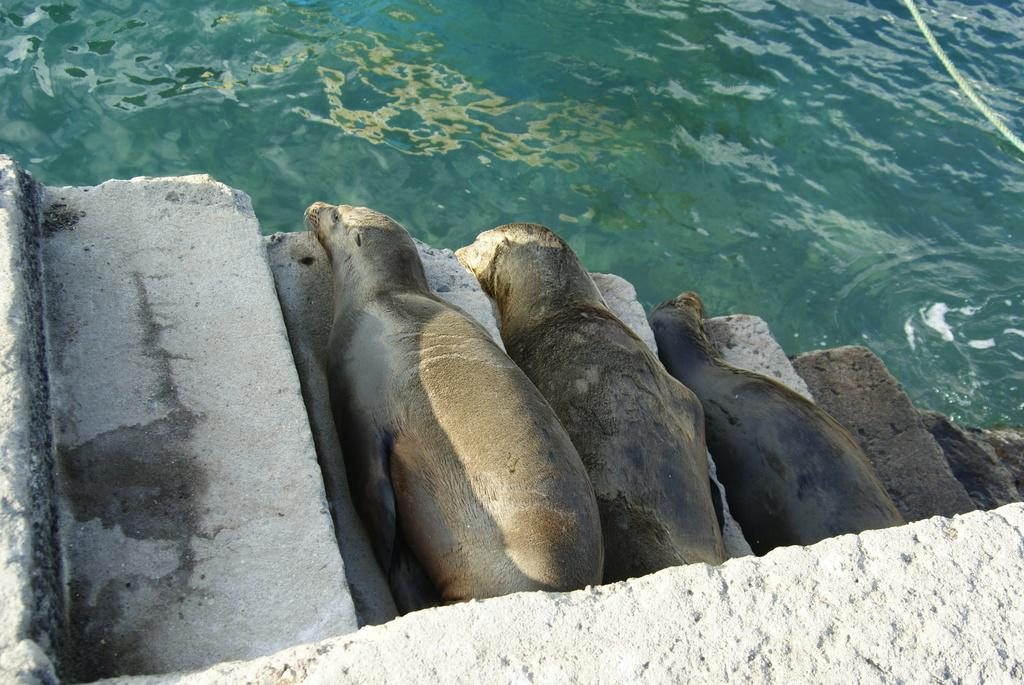What is the primary element in the image? There is water in the image. What is the color of the water? The water is blue in color. Are there any structures near the water? Yes, there are steps near the water. What are the sea lions doing in the image? The sea lions are sleeping on the steps. What type of angle is being used to take the picture of the body and line in the image? There is no body or line present in the image; it features water, blue color, steps, and sleeping sea lions. 